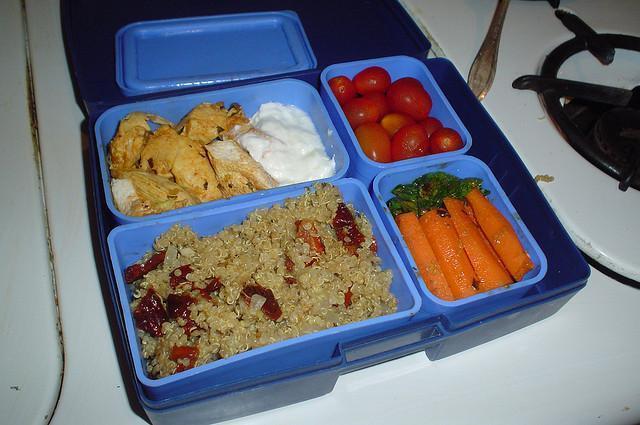How many different types of food are there?
Give a very brief answer. 6. How many squares are in this picture?
Give a very brief answer. 4. How many veggies are shown?
Give a very brief answer. 2. How many bowls can you see?
Give a very brief answer. 4. How many carrots are visible?
Give a very brief answer. 3. How many teddy bears are there?
Give a very brief answer. 0. 